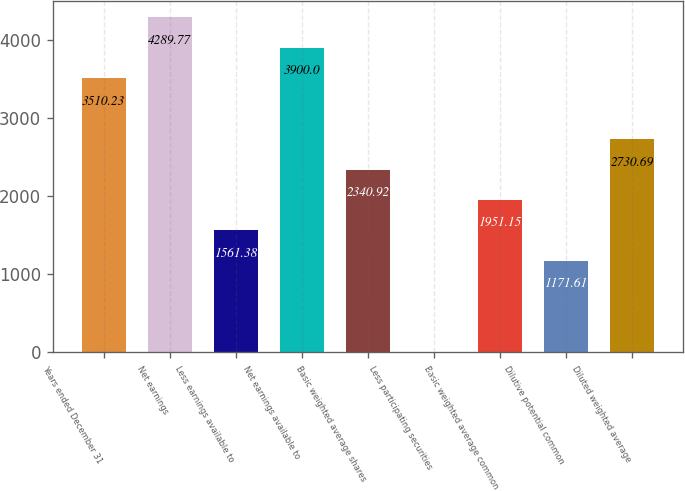Convert chart. <chart><loc_0><loc_0><loc_500><loc_500><bar_chart><fcel>Years ended December 31<fcel>Net earnings<fcel>Less earnings available to<fcel>Net earnings available to<fcel>Basic weighted average shares<fcel>Less participating securities<fcel>Basic weighted average common<fcel>Dilutive potential common<fcel>Diluted weighted average<nl><fcel>3510.23<fcel>4289.77<fcel>1561.38<fcel>3900<fcel>2340.92<fcel>2.3<fcel>1951.15<fcel>1171.61<fcel>2730.69<nl></chart> 